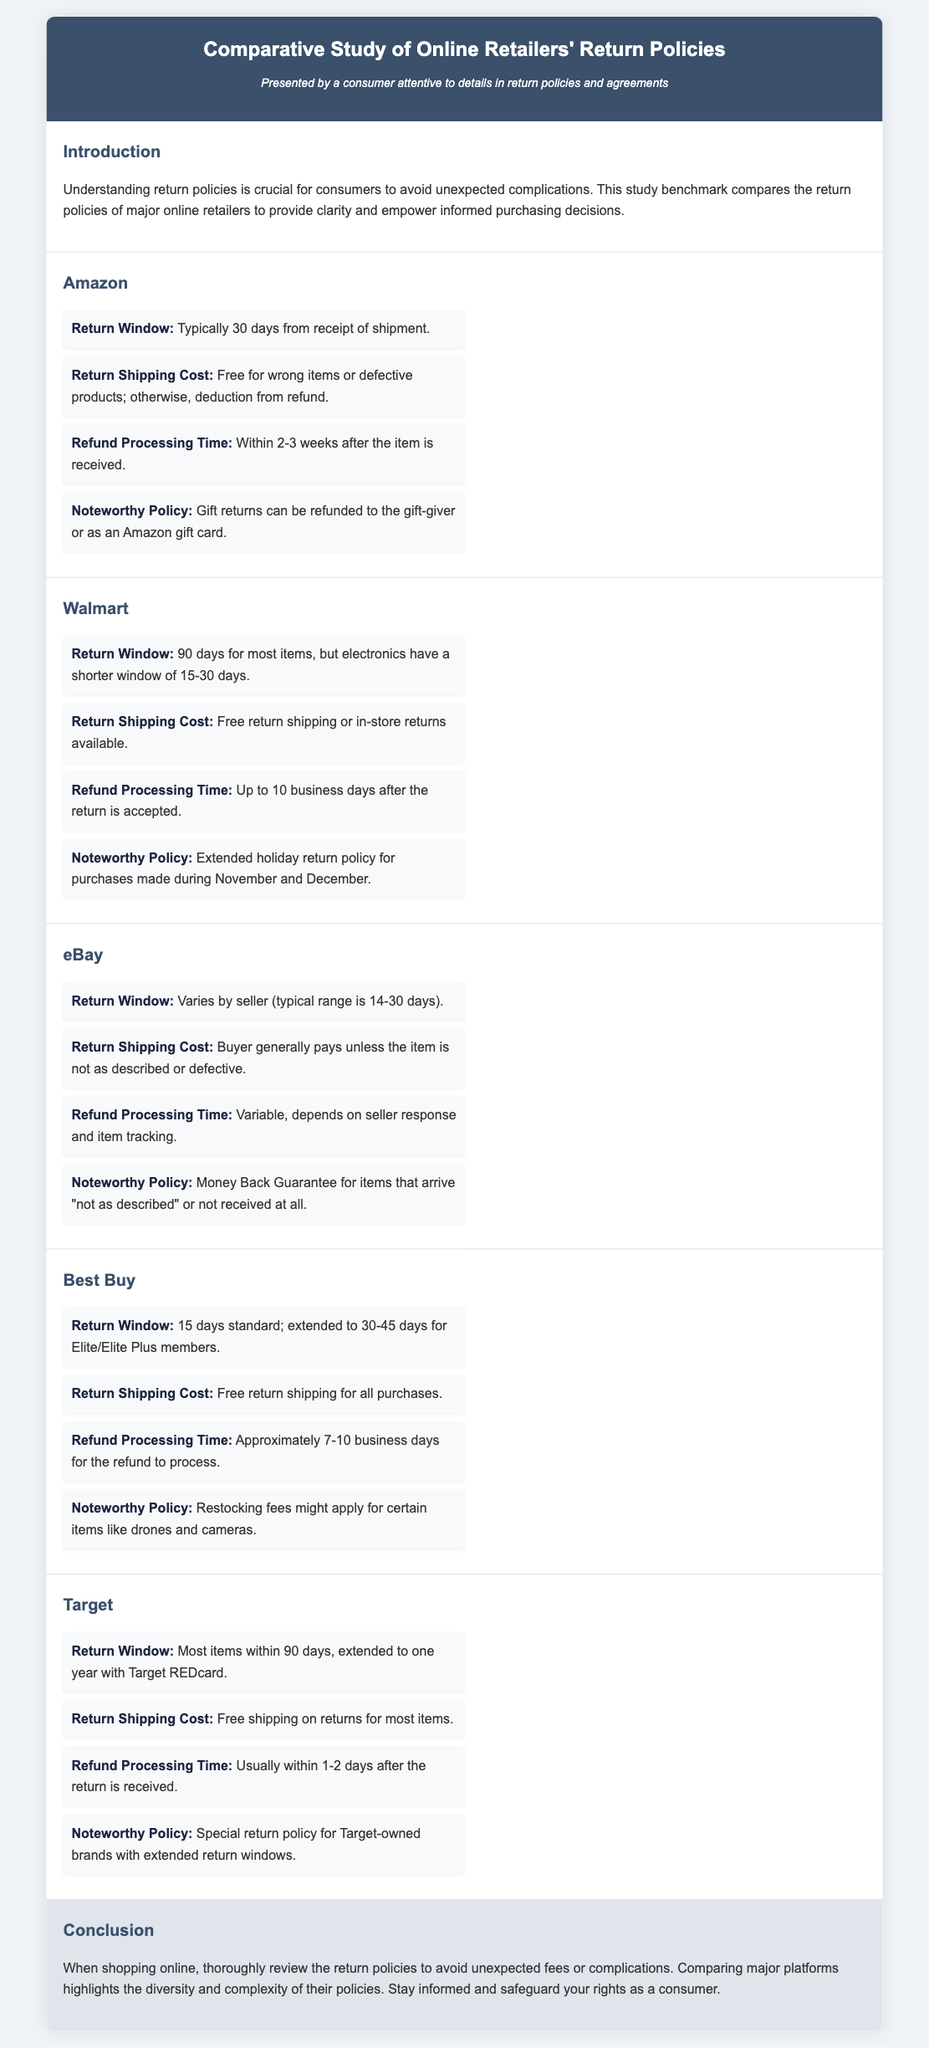what is the return window for Amazon? The return window for Amazon is typically 30 days from receipt of shipment.
Answer: 30 days how many days is Walmart's return window for electronics? Walmart's return window for electronics is shorter, typically 15-30 days.
Answer: 15-30 days who generally pays for return shipping on eBay? On eBay, the buyer generally pays for return shipping unless the item is not as described or defective.
Answer: Buyer what is Best Buy's standard return window? Best Buy's standard return window is 15 days.
Answer: 15 days what is the refund processing time for Target? The refund processing time for Target is usually within 1-2 days after the return is received.
Answer: 1-2 days which retailer has an extended return policy for purchases made during November and December? Walmart has an extended holiday return policy for purchases made during November and December.
Answer: Walmart how long does it take for Amazon to process refunds? Amazon's refund processing time is within 2-3 weeks after the item is received.
Answer: 2-3 weeks what is a noteworthy policy feature for eBay? A noteworthy policy for eBay is the Money Back Guarantee for items that arrive "not as described" or not received at all.
Answer: Money Back Guarantee what does Target REDcard provide in terms of return policy? Target REDcard extends the return window to one year for most items.
Answer: One year 